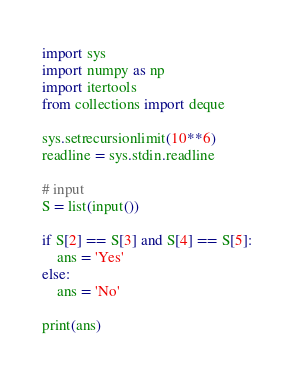<code> <loc_0><loc_0><loc_500><loc_500><_Python_>import sys
import numpy as np
import itertools
from collections import deque

sys.setrecursionlimit(10**6)
readline = sys.stdin.readline

# input
S = list(input())

if S[2] == S[3] and S[4] == S[5]:
    ans = 'Yes'
else:
    ans = 'No'

print(ans)
</code> 